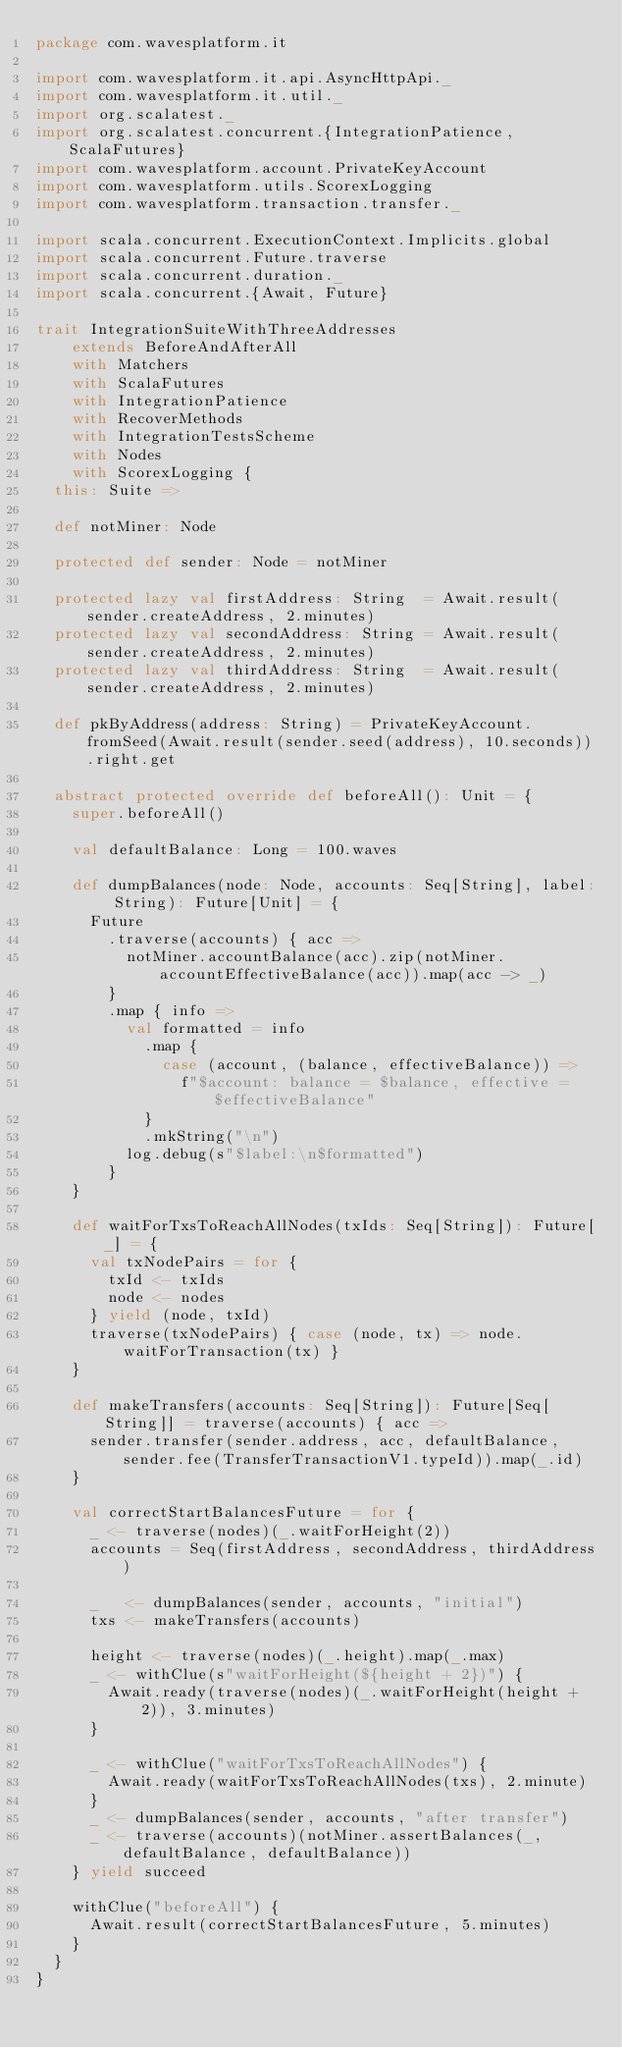Convert code to text. <code><loc_0><loc_0><loc_500><loc_500><_Scala_>package com.wavesplatform.it

import com.wavesplatform.it.api.AsyncHttpApi._
import com.wavesplatform.it.util._
import org.scalatest._
import org.scalatest.concurrent.{IntegrationPatience, ScalaFutures}
import com.wavesplatform.account.PrivateKeyAccount
import com.wavesplatform.utils.ScorexLogging
import com.wavesplatform.transaction.transfer._

import scala.concurrent.ExecutionContext.Implicits.global
import scala.concurrent.Future.traverse
import scala.concurrent.duration._
import scala.concurrent.{Await, Future}

trait IntegrationSuiteWithThreeAddresses
    extends BeforeAndAfterAll
    with Matchers
    with ScalaFutures
    with IntegrationPatience
    with RecoverMethods
    with IntegrationTestsScheme
    with Nodes
    with ScorexLogging {
  this: Suite =>

  def notMiner: Node

  protected def sender: Node = notMiner

  protected lazy val firstAddress: String  = Await.result(sender.createAddress, 2.minutes)
  protected lazy val secondAddress: String = Await.result(sender.createAddress, 2.minutes)
  protected lazy val thirdAddress: String  = Await.result(sender.createAddress, 2.minutes)

  def pkByAddress(address: String) = PrivateKeyAccount.fromSeed(Await.result(sender.seed(address), 10.seconds)).right.get

  abstract protected override def beforeAll(): Unit = {
    super.beforeAll()

    val defaultBalance: Long = 100.waves

    def dumpBalances(node: Node, accounts: Seq[String], label: String): Future[Unit] = {
      Future
        .traverse(accounts) { acc =>
          notMiner.accountBalance(acc).zip(notMiner.accountEffectiveBalance(acc)).map(acc -> _)
        }
        .map { info =>
          val formatted = info
            .map {
              case (account, (balance, effectiveBalance)) =>
                f"$account: balance = $balance, effective = $effectiveBalance"
            }
            .mkString("\n")
          log.debug(s"$label:\n$formatted")
        }
    }

    def waitForTxsToReachAllNodes(txIds: Seq[String]): Future[_] = {
      val txNodePairs = for {
        txId <- txIds
        node <- nodes
      } yield (node, txId)
      traverse(txNodePairs) { case (node, tx) => node.waitForTransaction(tx) }
    }

    def makeTransfers(accounts: Seq[String]): Future[Seq[String]] = traverse(accounts) { acc =>
      sender.transfer(sender.address, acc, defaultBalance, sender.fee(TransferTransactionV1.typeId)).map(_.id)
    }

    val correctStartBalancesFuture = for {
      _ <- traverse(nodes)(_.waitForHeight(2))
      accounts = Seq(firstAddress, secondAddress, thirdAddress)

      _   <- dumpBalances(sender, accounts, "initial")
      txs <- makeTransfers(accounts)

      height <- traverse(nodes)(_.height).map(_.max)
      _ <- withClue(s"waitForHeight(${height + 2})") {
        Await.ready(traverse(nodes)(_.waitForHeight(height + 2)), 3.minutes)
      }

      _ <- withClue("waitForTxsToReachAllNodes") {
        Await.ready(waitForTxsToReachAllNodes(txs), 2.minute)
      }
      _ <- dumpBalances(sender, accounts, "after transfer")
      _ <- traverse(accounts)(notMiner.assertBalances(_, defaultBalance, defaultBalance))
    } yield succeed

    withClue("beforeAll") {
      Await.result(correctStartBalancesFuture, 5.minutes)
    }
  }
}
</code> 